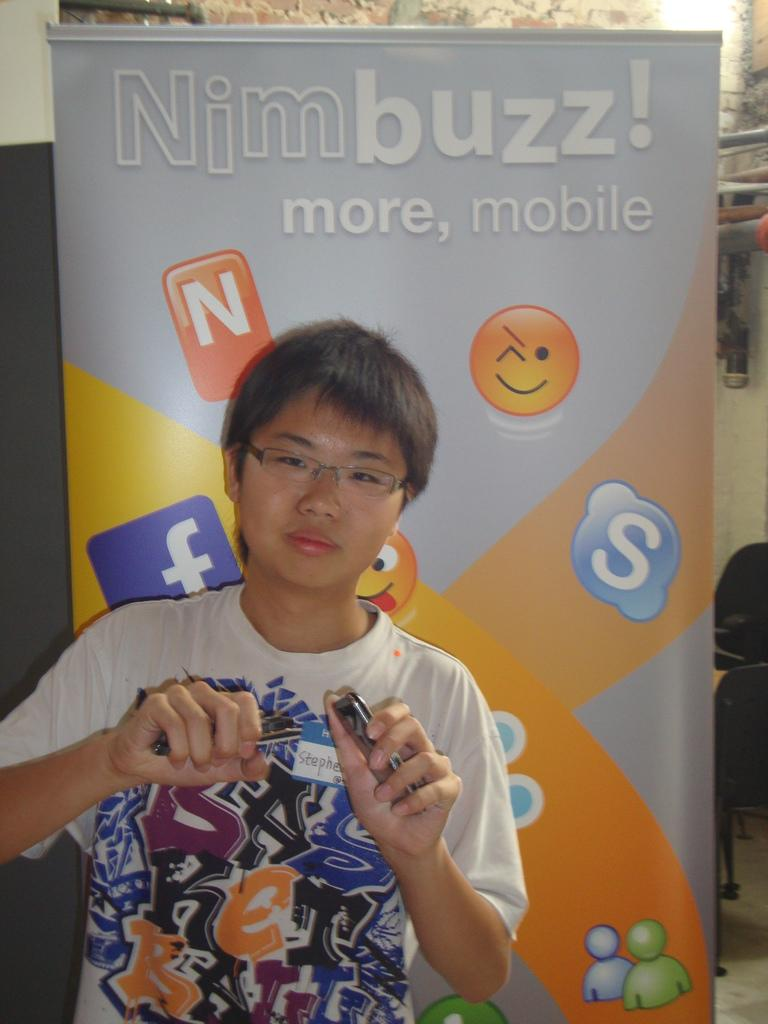<image>
Offer a succinct explanation of the picture presented. a kid showing cell phones made by nimbuzz moble 